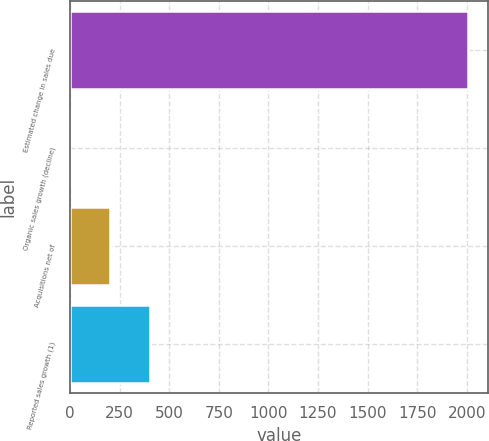Convert chart to OTSL. <chart><loc_0><loc_0><loc_500><loc_500><bar_chart><fcel>Estimated change in sales due<fcel>Organic sales growth (decline)<fcel>Acquisitions net of<fcel>Reported sales growth (1)<nl><fcel>2007<fcel>1<fcel>201.6<fcel>402.2<nl></chart> 